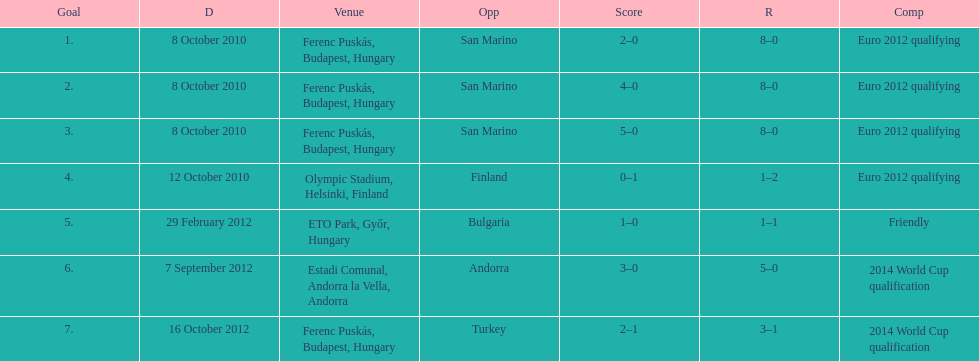What is the number of goals ádám szalai made against san marino in 2010? 3. 